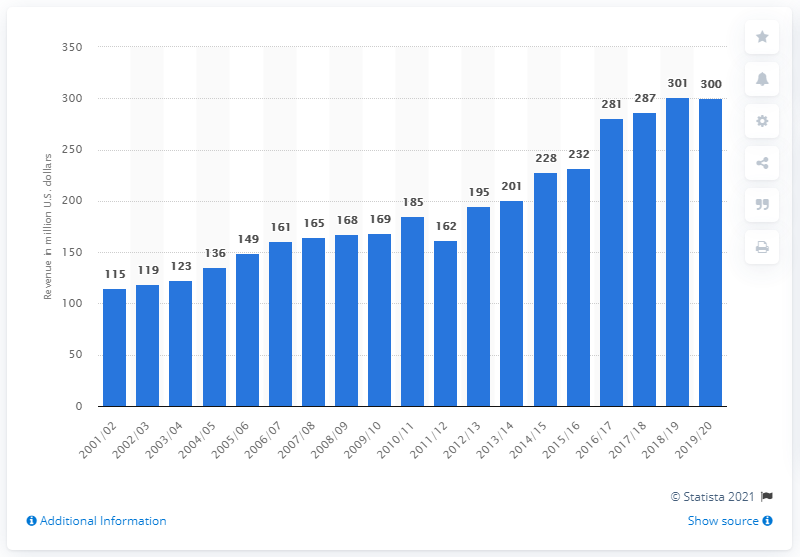Indicate a few pertinent items in this graphic. The estimated revenue of the National Basketball Association in the 2019/20 season was approximately 300. In the 2001/2002 season, the Chicago Bulls last placed in the rankings. In the 2019/2020 season, they have yet to make any notable progress. The last season of the Chicago Bulls was in the year 2001/2002. 